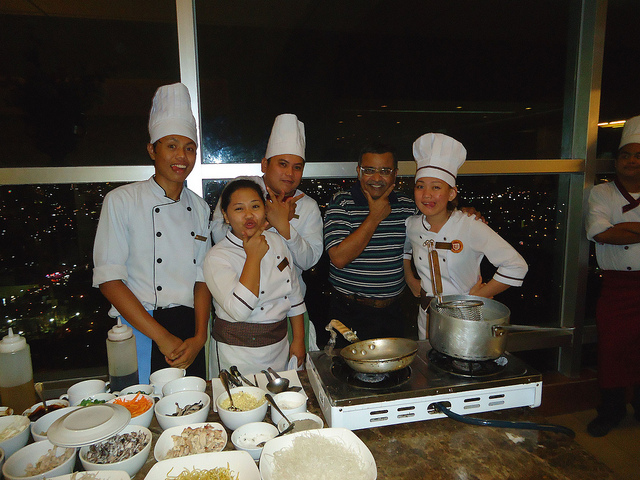<image>Which person is in the black hat? I am not sure which person is in the black hat. No one seems to be wearing a black hat. Which person is in the black hat? I am not sure which person is in the black hat. There is no one in the black hat in the image. 